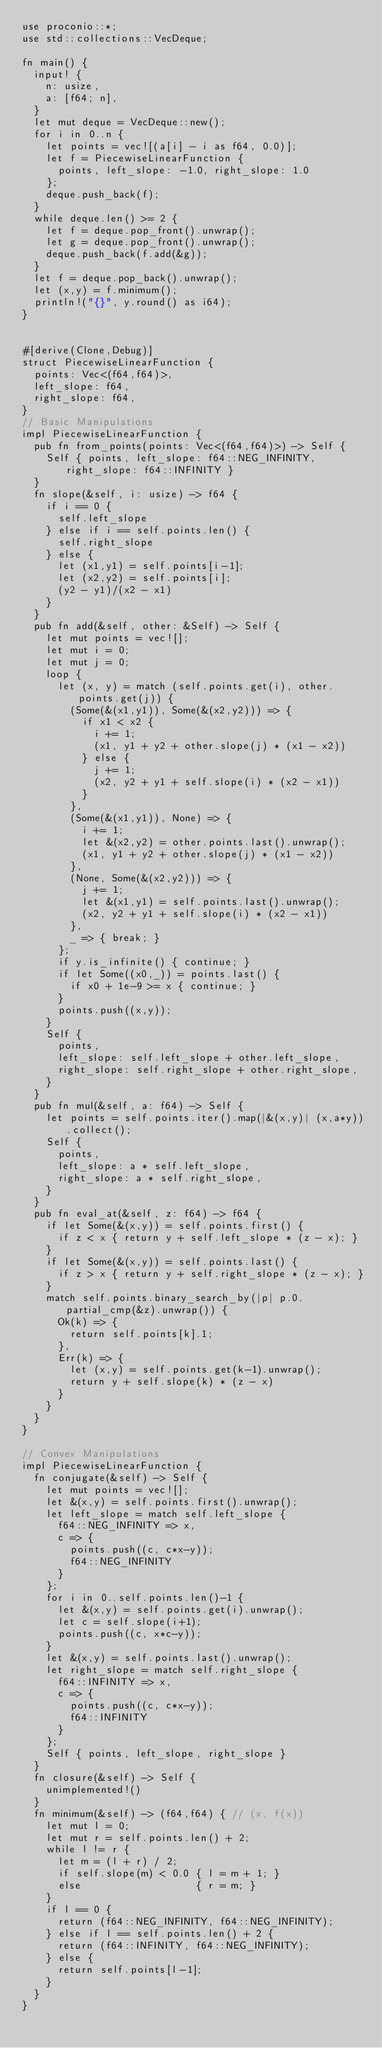<code> <loc_0><loc_0><loc_500><loc_500><_Rust_>use proconio::*;
use std::collections::VecDeque;

fn main() {
  input! {
    n: usize,
    a: [f64; n],
  }
  let mut deque = VecDeque::new();
  for i in 0..n {
    let points = vec![(a[i] - i as f64, 0.0)];
    let f = PiecewiseLinearFunction { 
      points, left_slope: -1.0, right_slope: 1.0
    };
    deque.push_back(f);
  }
  while deque.len() >= 2 {
    let f = deque.pop_front().unwrap();
    let g = deque.pop_front().unwrap();
    deque.push_back(f.add(&g));
  }
  let f = deque.pop_back().unwrap();
  let (x,y) = f.minimum();
  println!("{}", y.round() as i64);
}


#[derive(Clone,Debug)]
struct PiecewiseLinearFunction {
  points: Vec<(f64,f64)>,
  left_slope: f64,
  right_slope: f64,
}
// Basic Manipulations
impl PiecewiseLinearFunction {
  pub fn from_points(points: Vec<(f64,f64)>) -> Self {
    Self { points, left_slope: f64::NEG_INFINITY, right_slope: f64::INFINITY }
  }
  fn slope(&self, i: usize) -> f64 {
    if i == 0 {
      self.left_slope
    } else if i == self.points.len() {
      self.right_slope
    } else {
      let (x1,y1) = self.points[i-1];
      let (x2,y2) = self.points[i];
      (y2 - y1)/(x2 - x1)
    }
  }
  pub fn add(&self, other: &Self) -> Self {
    let mut points = vec![];
    let mut i = 0;
    let mut j = 0;
    loop { 
      let (x, y) = match (self.points.get(i), other.points.get(j)) {
        (Some(&(x1,y1)), Some(&(x2,y2))) => { 
          if x1 < x2 {
            i += 1;
            (x1, y1 + y2 + other.slope(j) * (x1 - x2))
          } else {
            j += 1;
            (x2, y2 + y1 + self.slope(i) * (x2 - x1))
          }
        },
        (Some(&(x1,y1)), None) => {
          i += 1;
          let &(x2,y2) = other.points.last().unwrap();
          (x1, y1 + y2 + other.slope(j) * (x1 - x2))
        },
        (None, Some(&(x2,y2))) => {
          j += 1;
          let &(x1,y1) = self.points.last().unwrap();
          (x2, y2 + y1 + self.slope(i) * (x2 - x1))
        },
        _ => { break; }
      };
      if y.is_infinite() { continue; }
      if let Some((x0,_)) = points.last() {
        if x0 + 1e-9 >= x { continue; }
      }
      points.push((x,y));
    }
    Self { 
      points, 
      left_slope: self.left_slope + other.left_slope, 
      right_slope: self.right_slope + other.right_slope,
    }
  }
  pub fn mul(&self, a: f64) -> Self {
    let points = self.points.iter().map(|&(x,y)| (x,a*y)).collect();
    Self { 
      points, 
      left_slope: a * self.left_slope,
      right_slope: a * self.right_slope,
    }
  }
  pub fn eval_at(&self, z: f64) -> f64 {
    if let Some(&(x,y)) = self.points.first() {
      if z < x { return y + self.left_slope * (z - x); }
    }
    if let Some(&(x,y)) = self.points.last() {
      if z > x { return y + self.right_slope * (z - x); }
    }
    match self.points.binary_search_by(|p| p.0.partial_cmp(&z).unwrap()) {
      Ok(k) => {
        return self.points[k].1;
      },
      Err(k) => {
        let (x,y) = self.points.get(k-1).unwrap();
        return y + self.slope(k) * (z - x)
      }
    }
  }
}

// Convex Manipulations
impl PiecewiseLinearFunction {
  fn conjugate(&self) -> Self {
    let mut points = vec![];
    let &(x,y) = self.points.first().unwrap();
    let left_slope = match self.left_slope {
      f64::NEG_INFINITY => x,
      c => {
        points.push((c, c*x-y));
        f64::NEG_INFINITY
      }
    };
    for i in 0..self.points.len()-1 {
      let &(x,y) = self.points.get(i).unwrap();
      let c = self.slope(i+1);
      points.push((c, x*c-y));
    }
    let &(x,y) = self.points.last().unwrap();
    let right_slope = match self.right_slope {
      f64::INFINITY => x,
      c => {
        points.push((c, c*x-y));
        f64::INFINITY
      }
    };
    Self { points, left_slope, right_slope }
  }
  fn closure(&self) -> Self {
    unimplemented!()
  }
  fn minimum(&self) -> (f64,f64) { // (x, f(x))
    let mut l = 0;
    let mut r = self.points.len() + 2;
    while l != r {
      let m = (l + r) / 2;
      if self.slope(m) < 0.0 { l = m + 1; }
      else                   { r = m; }
    }
    if l == 0 { 
      return (f64::NEG_INFINITY, f64::NEG_INFINITY);
    } else if l == self.points.len() + 2 {
      return (f64::INFINITY, f64::NEG_INFINITY);
    } else {
      return self.points[l-1];
    }
  }
}

</code> 